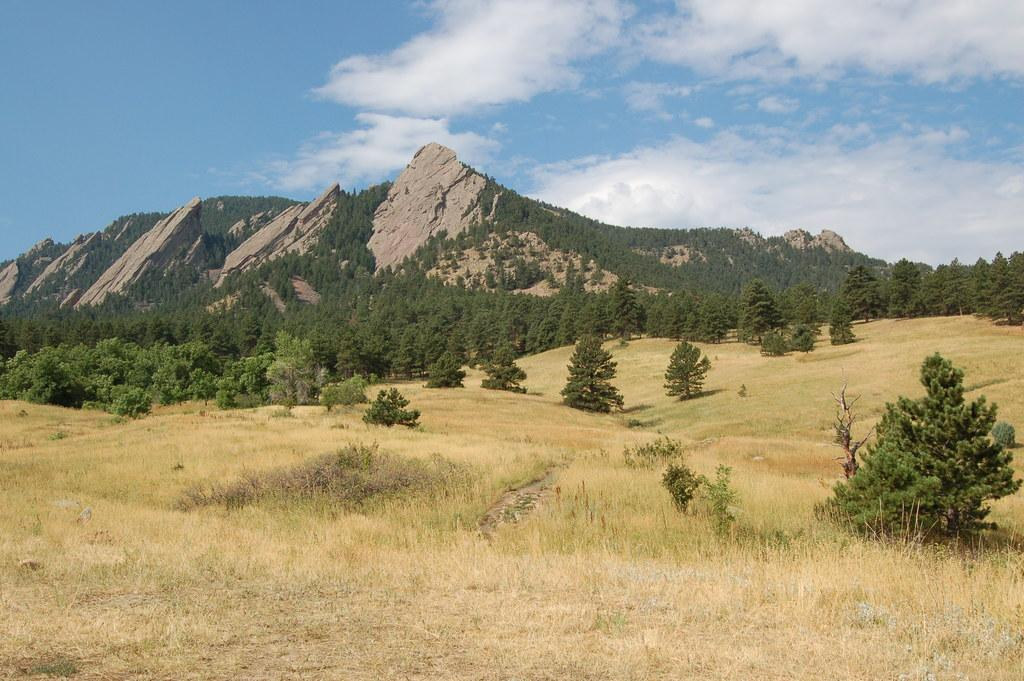What type of natural landform can be seen in the image? There are mountains in the image. What type of vegetation is visible at the bottom of the image? There is grass visible at the bottom of the image. How many trees can be seen in the image? There are many trees in the image. What is visible at the top of the image? The sky is visible at the top of the image. What is present in the sky? Clouds are present in the sky. What question is being asked in the image? There is no question being asked in the image; it is a visual representation of mountains, grass, trees, sky, and clouds. How does the fog affect the visibility in the image? There is no fog present in the image, so its effect on visibility cannot be determined. 